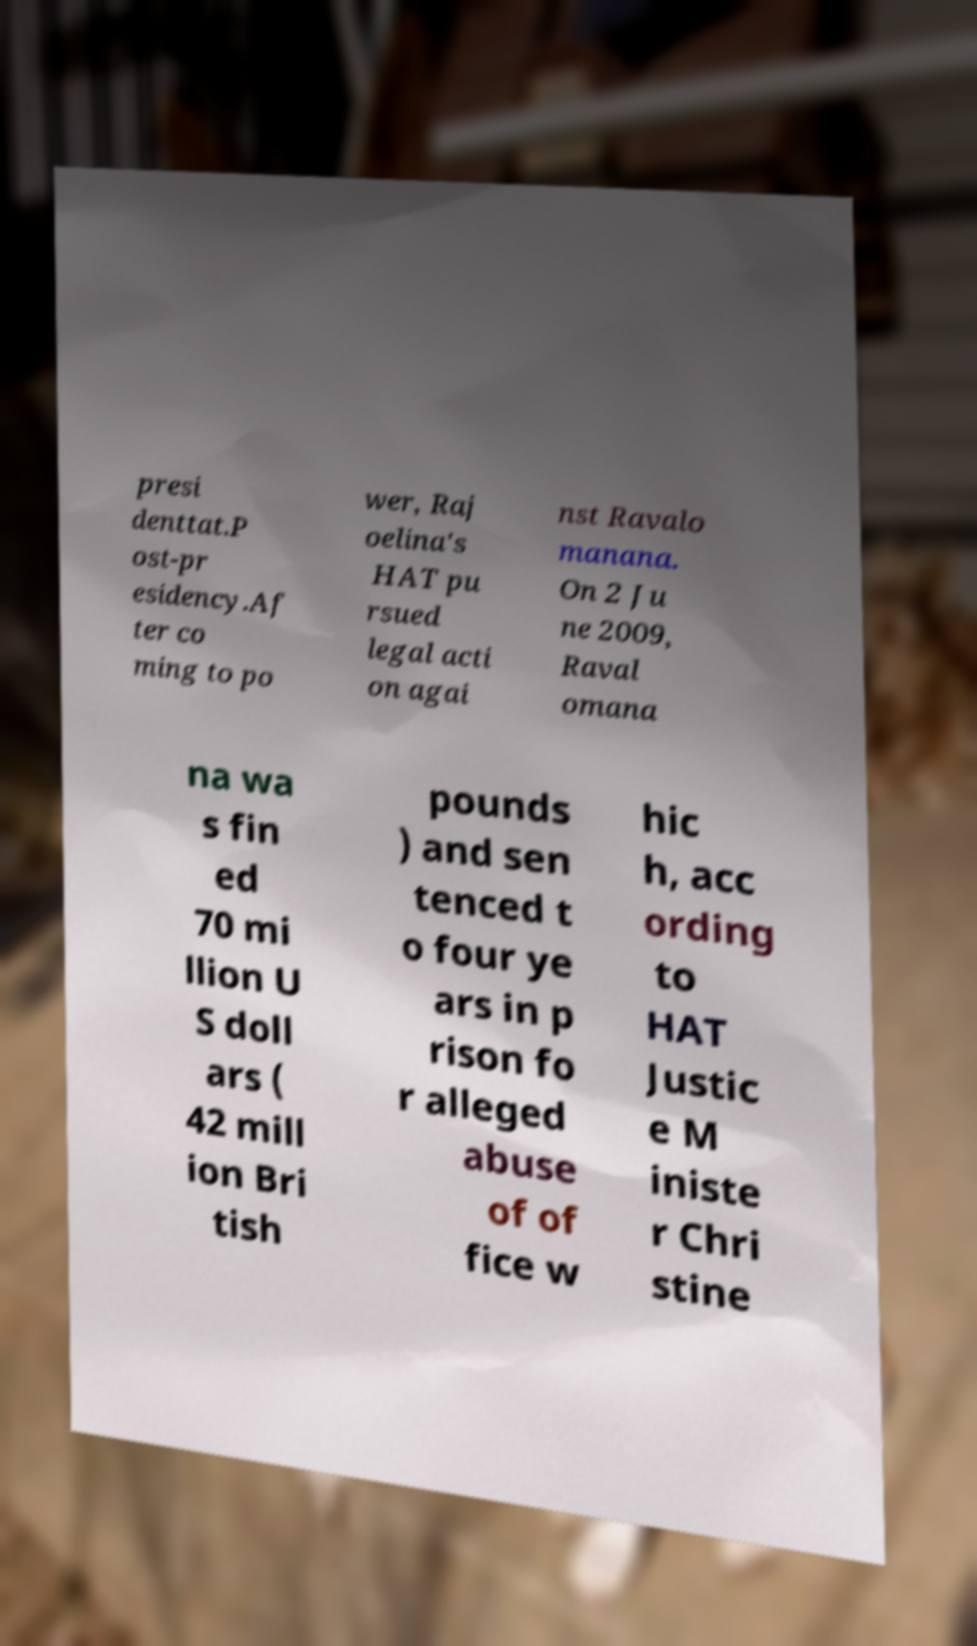Could you assist in decoding the text presented in this image and type it out clearly? presi denttat.P ost-pr esidency.Af ter co ming to po wer, Raj oelina's HAT pu rsued legal acti on agai nst Ravalo manana. On 2 Ju ne 2009, Raval omana na wa s fin ed 70 mi llion U S doll ars ( 42 mill ion Bri tish pounds ) and sen tenced t o four ye ars in p rison fo r alleged abuse of of fice w hic h, acc ording to HAT Justic e M iniste r Chri stine 